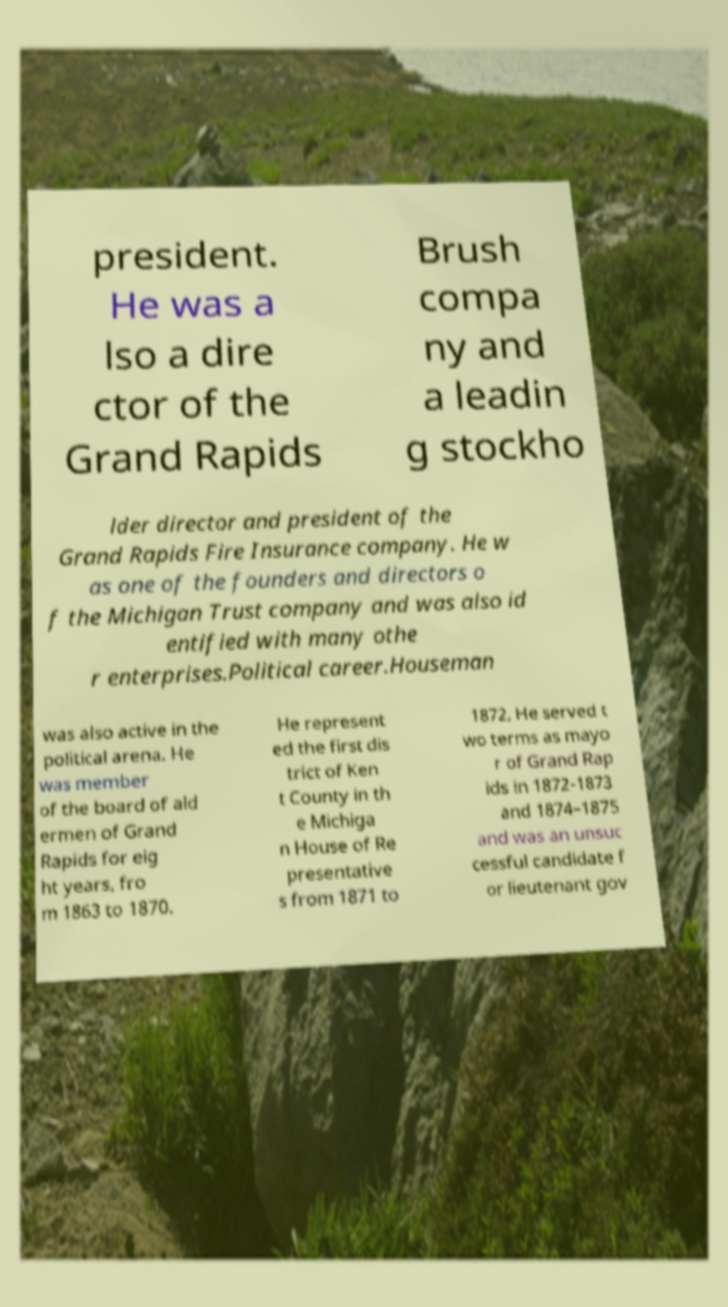For documentation purposes, I need the text within this image transcribed. Could you provide that? president. He was a lso a dire ctor of the Grand Rapids Brush compa ny and a leadin g stockho lder director and president of the Grand Rapids Fire Insurance company. He w as one of the founders and directors o f the Michigan Trust company and was also id entified with many othe r enterprises.Political career.Houseman was also active in the political arena. He was member of the board of ald ermen of Grand Rapids for eig ht years, fro m 1863 to 1870. He represent ed the first dis trict of Ken t County in th e Michiga n House of Re presentative s from 1871 to 1872, He served t wo terms as mayo r of Grand Rap ids in 1872-1873 and 1874–1875 and was an unsuc cessful candidate f or lieutenant gov 